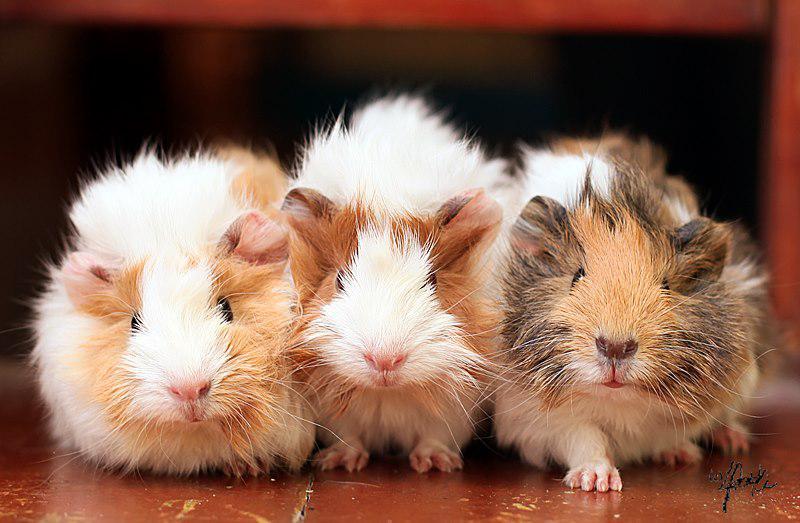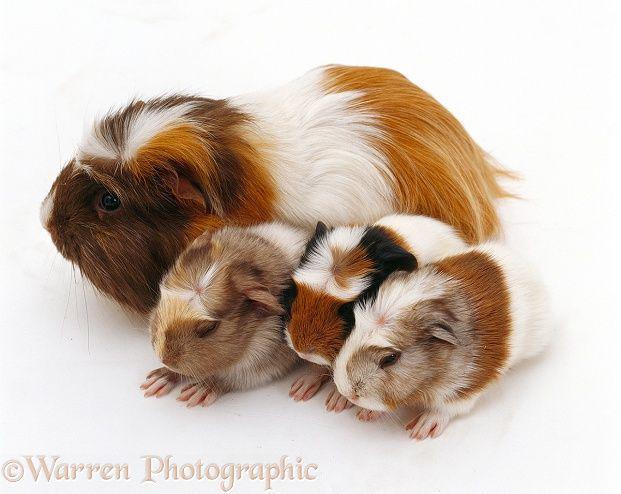The first image is the image on the left, the second image is the image on the right. Assess this claim about the two images: "there are 3 guinea pigs in each image pair". Correct or not? Answer yes or no. No. The first image is the image on the left, the second image is the image on the right. Given the left and right images, does the statement "In the right image, the animals have something covering their heads." hold true? Answer yes or no. No. 